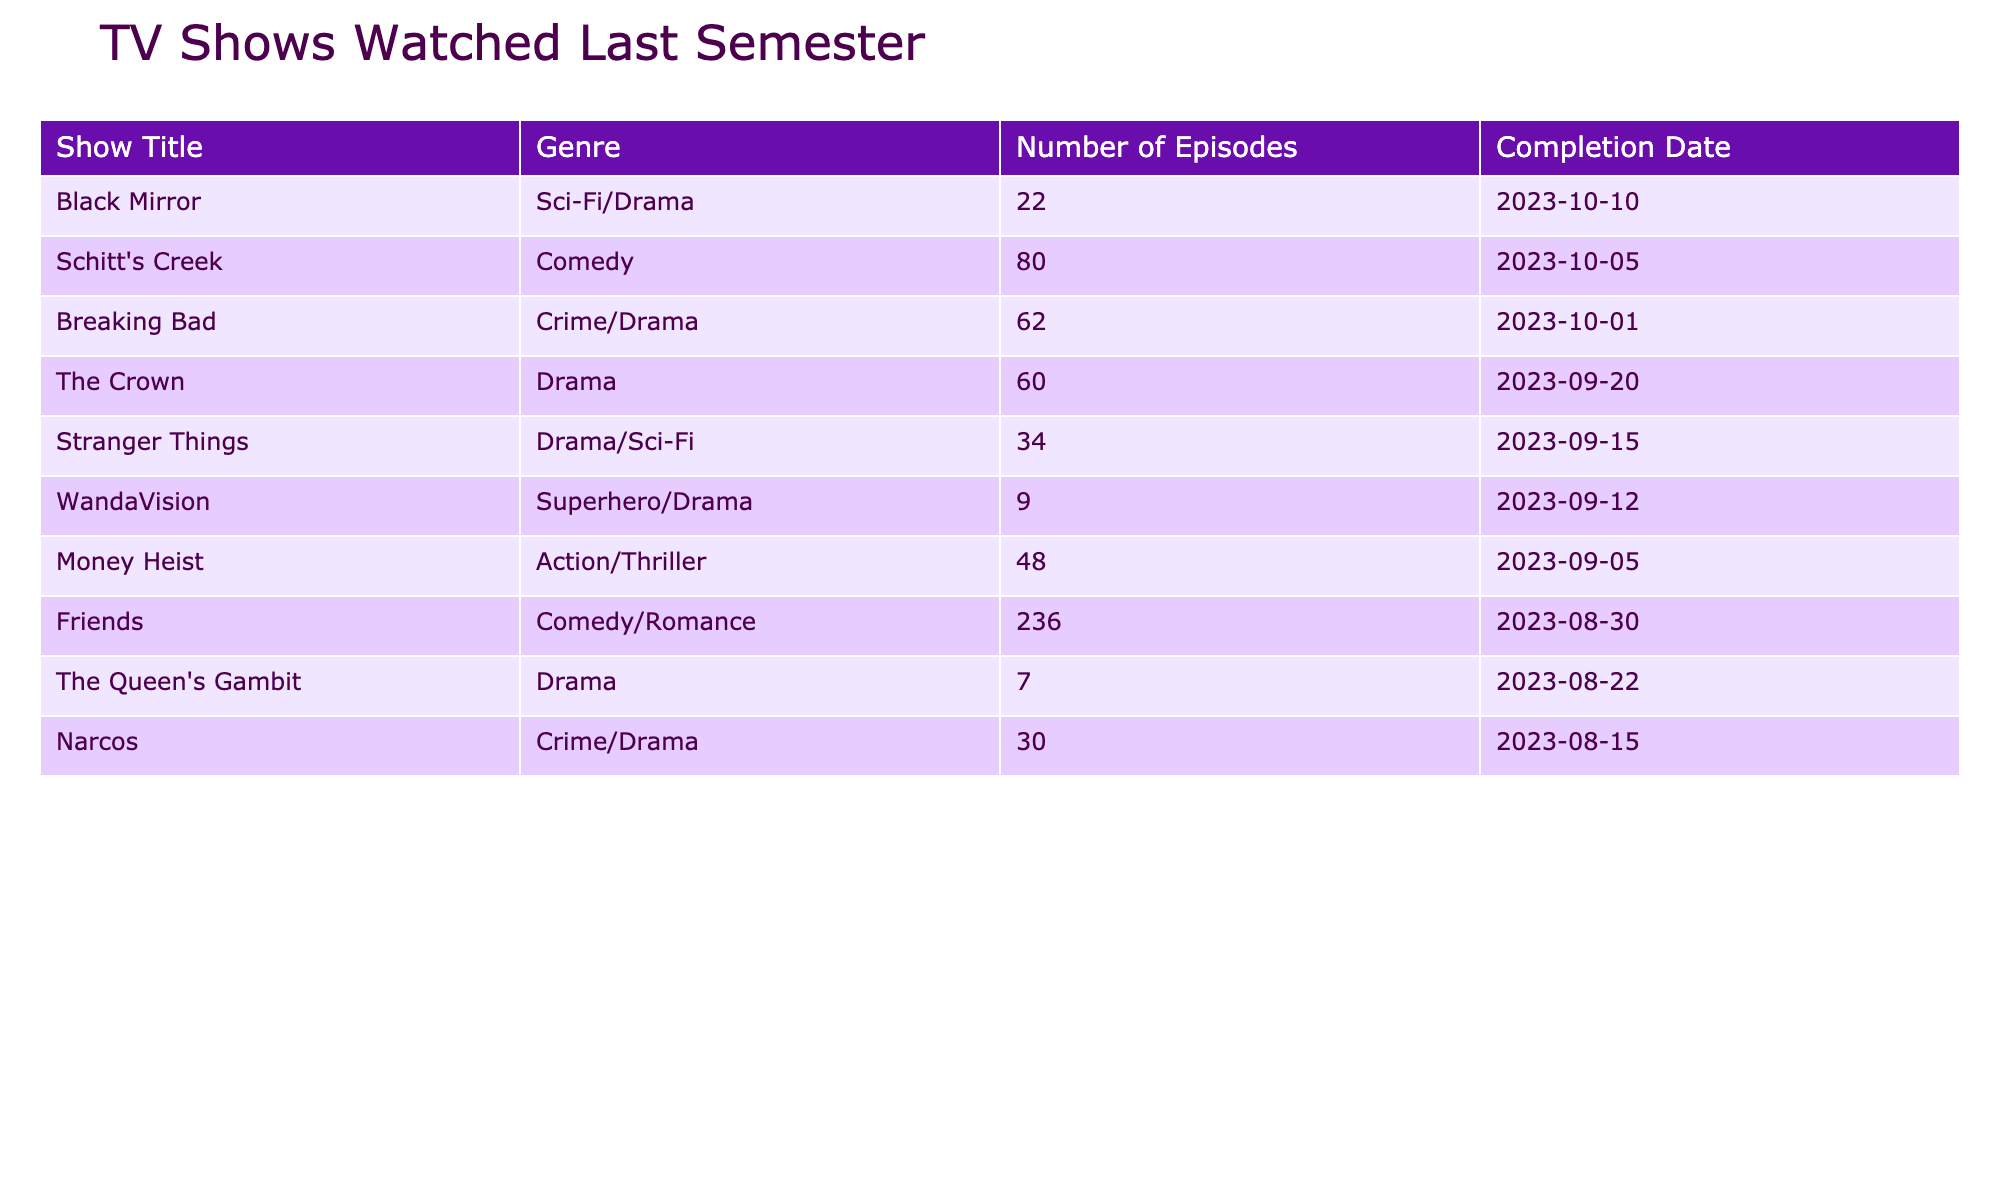What is the genre of "Money Heist"? By looking at the "Genre" column in the table, we can see the entry for "Money Heist". It states that its genre is Action/Thriller.
Answer: Action/Thriller How many episodes are in "Breaking Bad"? In the "Number of Episodes" column, the entry for "Breaking Bad" indicates that it has 62 episodes.
Answer: 62 Which show has the highest number of episodes? To find the show with the highest number of episodes, we compare the "Number of Episodes" column. "Friends" has 236 episodes, which is the highest count among all shows listed.
Answer: Friends Is there a show that was completed on the same date as "The Crown"? By checking the "Completion Date" column, we can confirm that the completion date for "The Crown" is 2023-09-20. There is no other show listed in the table that has the same completion date.
Answer: No What is the total number of episodes for all the shows completed in the last semester? To find the total number of episodes, we can sum up the "Number of Episodes" column: 34 + 7 + 62 + 48 + 236 + 60 + 22 + 30 + 9 + 80 = 388. Therefore, the total number of episodes is 388.
Answer: 388 How many shows in total were completed before the end of September 2023? By looking at the "Completion Date" column, we see that the shows completed before 2023-09-30 are "Stranger Things", "The Queen's Gambit", "Money Heist", "Friends", "The Crown", and "Narcos". Counting these gives us 6 shows in total.
Answer: 6 Which show was completed last? We can determine which show was completed last by checking the "Completion Date" column. "Breaking Bad" shows a completion date of 2023-10-01, which is later than all others listed.
Answer: Breaking Bad What is the average number of episodes for the shows completed by the end of August 2023? First, we identify the shows completed by the end of August: "The Queen's Gambit" (7), "Narcos" (30), and "Friends" (236). The total number of episodes is 273 (7 + 30 + 236), and there are 3 shows. Thus, the average is 273 / 3 = 91.
Answer: 91 Was "Black Mirror" completed after "WandaVision"? Looking at the "Completion Date" column, "Black Mirror" was completed on 2023-10-10, while "WandaVision" was completed on 2023-09-12. Since 2023-10-10 is later than 2023-09-12, the answer is yes.
Answer: Yes 